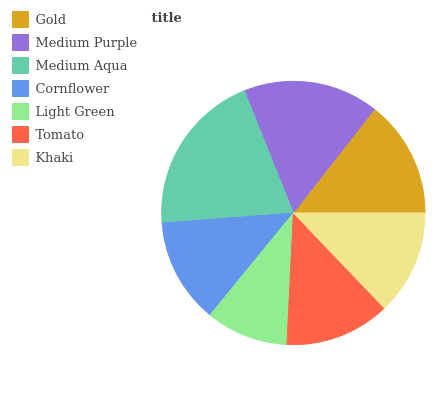Is Light Green the minimum?
Answer yes or no. Yes. Is Medium Aqua the maximum?
Answer yes or no. Yes. Is Medium Purple the minimum?
Answer yes or no. No. Is Medium Purple the maximum?
Answer yes or no. No. Is Medium Purple greater than Gold?
Answer yes or no. Yes. Is Gold less than Medium Purple?
Answer yes or no. Yes. Is Gold greater than Medium Purple?
Answer yes or no. No. Is Medium Purple less than Gold?
Answer yes or no. No. Is Tomato the high median?
Answer yes or no. Yes. Is Tomato the low median?
Answer yes or no. Yes. Is Khaki the high median?
Answer yes or no. No. Is Cornflower the low median?
Answer yes or no. No. 